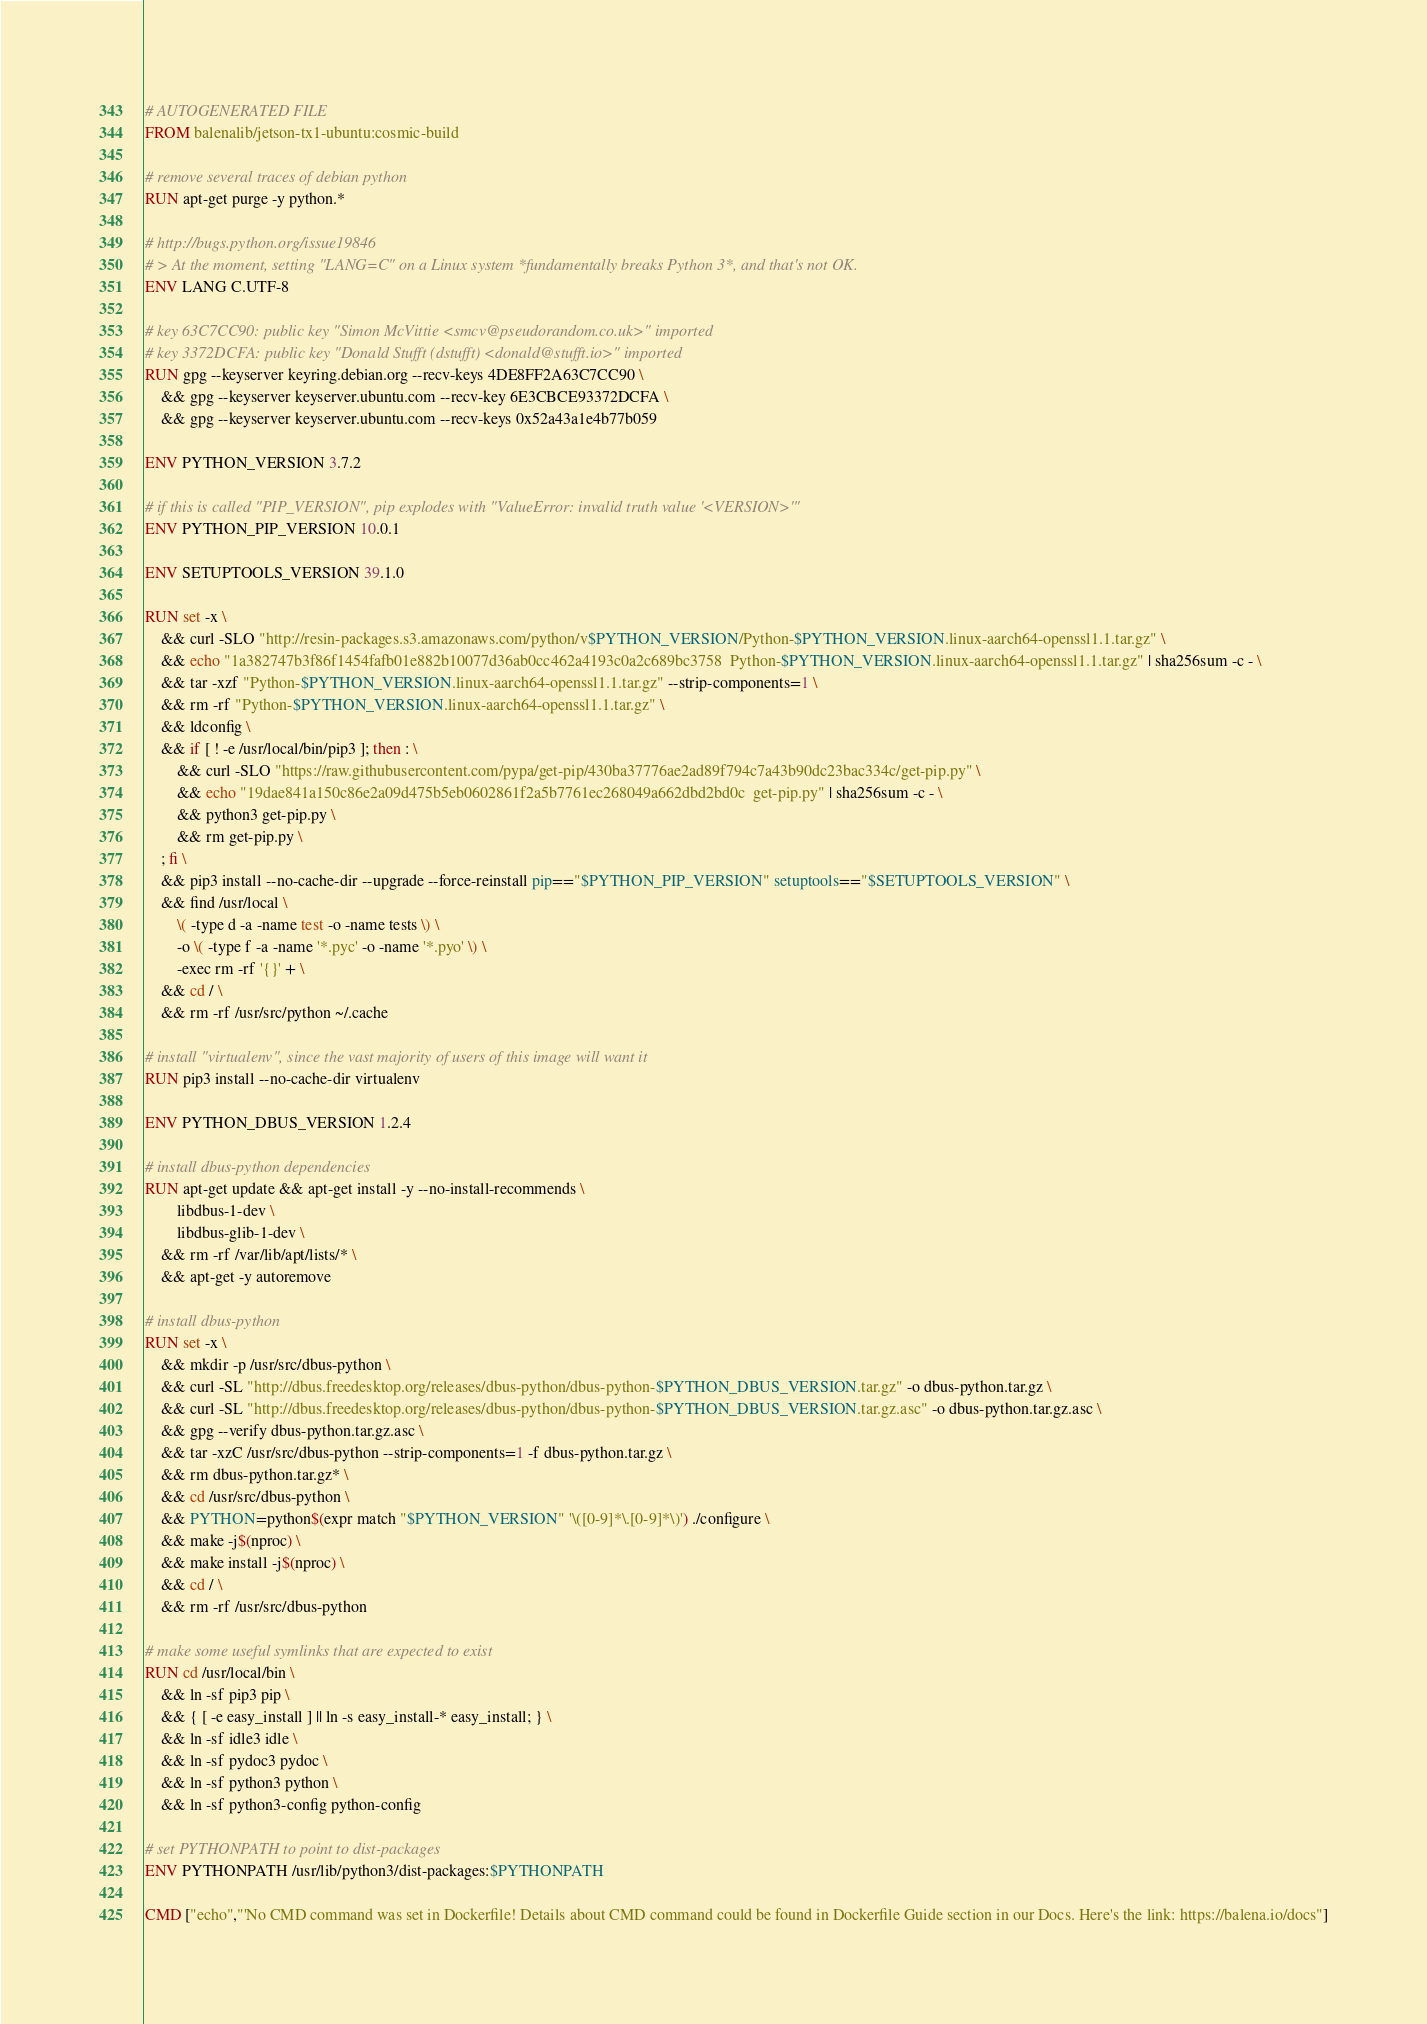Convert code to text. <code><loc_0><loc_0><loc_500><loc_500><_Dockerfile_># AUTOGENERATED FILE
FROM balenalib/jetson-tx1-ubuntu:cosmic-build

# remove several traces of debian python
RUN apt-get purge -y python.*

# http://bugs.python.org/issue19846
# > At the moment, setting "LANG=C" on a Linux system *fundamentally breaks Python 3*, and that's not OK.
ENV LANG C.UTF-8

# key 63C7CC90: public key "Simon McVittie <smcv@pseudorandom.co.uk>" imported
# key 3372DCFA: public key "Donald Stufft (dstufft) <donald@stufft.io>" imported
RUN gpg --keyserver keyring.debian.org --recv-keys 4DE8FF2A63C7CC90 \
	&& gpg --keyserver keyserver.ubuntu.com --recv-key 6E3CBCE93372DCFA \
	&& gpg --keyserver keyserver.ubuntu.com --recv-keys 0x52a43a1e4b77b059

ENV PYTHON_VERSION 3.7.2

# if this is called "PIP_VERSION", pip explodes with "ValueError: invalid truth value '<VERSION>'"
ENV PYTHON_PIP_VERSION 10.0.1

ENV SETUPTOOLS_VERSION 39.1.0

RUN set -x \
	&& curl -SLO "http://resin-packages.s3.amazonaws.com/python/v$PYTHON_VERSION/Python-$PYTHON_VERSION.linux-aarch64-openssl1.1.tar.gz" \
	&& echo "1a382747b3f86f1454fafb01e882b10077d36ab0cc462a4193c0a2c689bc3758  Python-$PYTHON_VERSION.linux-aarch64-openssl1.1.tar.gz" | sha256sum -c - \
	&& tar -xzf "Python-$PYTHON_VERSION.linux-aarch64-openssl1.1.tar.gz" --strip-components=1 \
	&& rm -rf "Python-$PYTHON_VERSION.linux-aarch64-openssl1.1.tar.gz" \
	&& ldconfig \
	&& if [ ! -e /usr/local/bin/pip3 ]; then : \
		&& curl -SLO "https://raw.githubusercontent.com/pypa/get-pip/430ba37776ae2ad89f794c7a43b90dc23bac334c/get-pip.py" \
		&& echo "19dae841a150c86e2a09d475b5eb0602861f2a5b7761ec268049a662dbd2bd0c  get-pip.py" | sha256sum -c - \
		&& python3 get-pip.py \
		&& rm get-pip.py \
	; fi \
	&& pip3 install --no-cache-dir --upgrade --force-reinstall pip=="$PYTHON_PIP_VERSION" setuptools=="$SETUPTOOLS_VERSION" \
	&& find /usr/local \
		\( -type d -a -name test -o -name tests \) \
		-o \( -type f -a -name '*.pyc' -o -name '*.pyo' \) \
		-exec rm -rf '{}' + \
	&& cd / \
	&& rm -rf /usr/src/python ~/.cache

# install "virtualenv", since the vast majority of users of this image will want it
RUN pip3 install --no-cache-dir virtualenv

ENV PYTHON_DBUS_VERSION 1.2.4

# install dbus-python dependencies 
RUN apt-get update && apt-get install -y --no-install-recommends \
		libdbus-1-dev \
		libdbus-glib-1-dev \
	&& rm -rf /var/lib/apt/lists/* \
	&& apt-get -y autoremove

# install dbus-python
RUN set -x \
	&& mkdir -p /usr/src/dbus-python \
	&& curl -SL "http://dbus.freedesktop.org/releases/dbus-python/dbus-python-$PYTHON_DBUS_VERSION.tar.gz" -o dbus-python.tar.gz \
	&& curl -SL "http://dbus.freedesktop.org/releases/dbus-python/dbus-python-$PYTHON_DBUS_VERSION.tar.gz.asc" -o dbus-python.tar.gz.asc \
	&& gpg --verify dbus-python.tar.gz.asc \
	&& tar -xzC /usr/src/dbus-python --strip-components=1 -f dbus-python.tar.gz \
	&& rm dbus-python.tar.gz* \
	&& cd /usr/src/dbus-python \
	&& PYTHON=python$(expr match "$PYTHON_VERSION" '\([0-9]*\.[0-9]*\)') ./configure \
	&& make -j$(nproc) \
	&& make install -j$(nproc) \
	&& cd / \
	&& rm -rf /usr/src/dbus-python

# make some useful symlinks that are expected to exist
RUN cd /usr/local/bin \
	&& ln -sf pip3 pip \
	&& { [ -e easy_install ] || ln -s easy_install-* easy_install; } \
	&& ln -sf idle3 idle \
	&& ln -sf pydoc3 pydoc \
	&& ln -sf python3 python \
	&& ln -sf python3-config python-config

# set PYTHONPATH to point to dist-packages
ENV PYTHONPATH /usr/lib/python3/dist-packages:$PYTHONPATH

CMD ["echo","'No CMD command was set in Dockerfile! Details about CMD command could be found in Dockerfile Guide section in our Docs. Here's the link: https://balena.io/docs"]</code> 